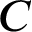<formula> <loc_0><loc_0><loc_500><loc_500>C</formula> 